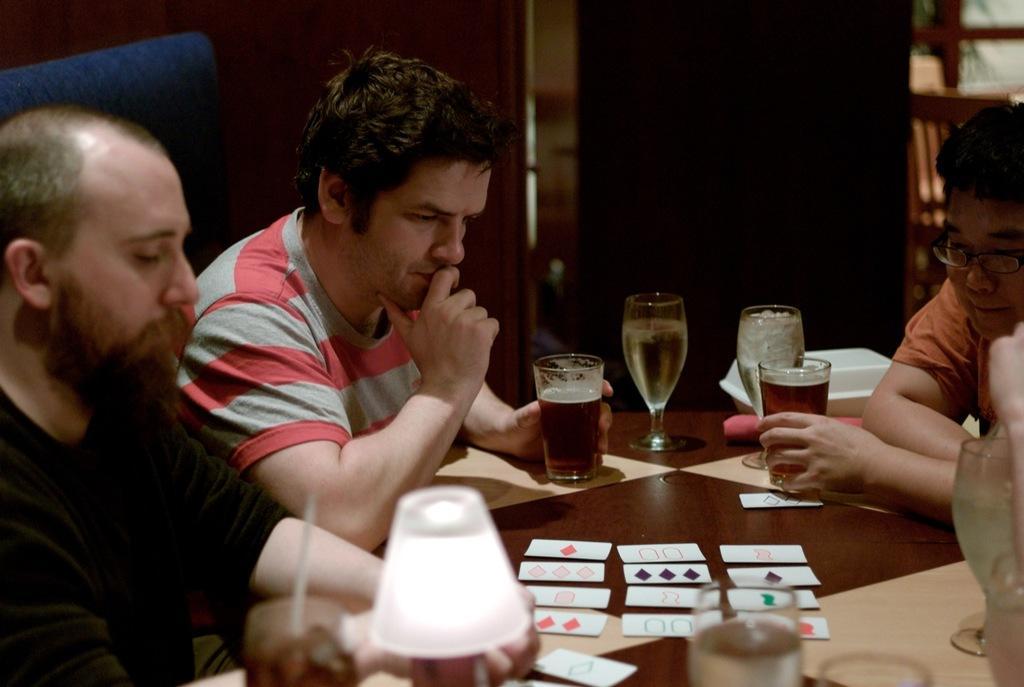Please provide a concise description of this image. As we can see in the image there are three people sitting on chairs and there is a table. On table there are cards and glasses. 